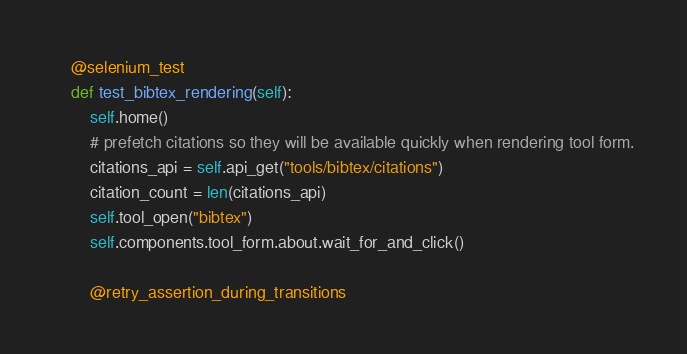<code> <loc_0><loc_0><loc_500><loc_500><_Python_>
    @selenium_test
    def test_bibtex_rendering(self):
        self.home()
        # prefetch citations so they will be available quickly when rendering tool form.
        citations_api = self.api_get("tools/bibtex/citations")
        citation_count = len(citations_api)
        self.tool_open("bibtex")
        self.components.tool_form.about.wait_for_and_click()

        @retry_assertion_during_transitions</code> 